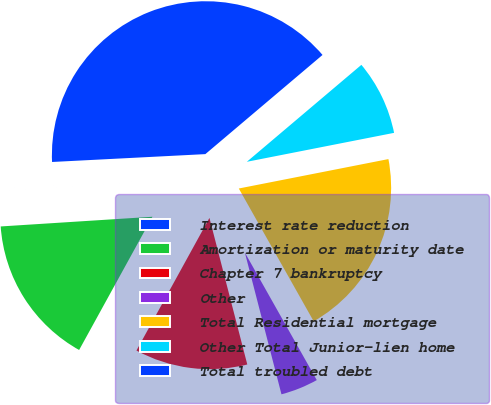Convert chart to OTSL. <chart><loc_0><loc_0><loc_500><loc_500><pie_chart><fcel>Interest rate reduction<fcel>Amortization or maturity date<fcel>Chapter 7 bankruptcy<fcel>Other<fcel>Total Residential mortgage<fcel>Other Total Junior-lien home<fcel>Total troubled debt<nl><fcel>0.2%<fcel>15.98%<fcel>12.03%<fcel>4.15%<fcel>19.92%<fcel>8.09%<fcel>39.64%<nl></chart> 